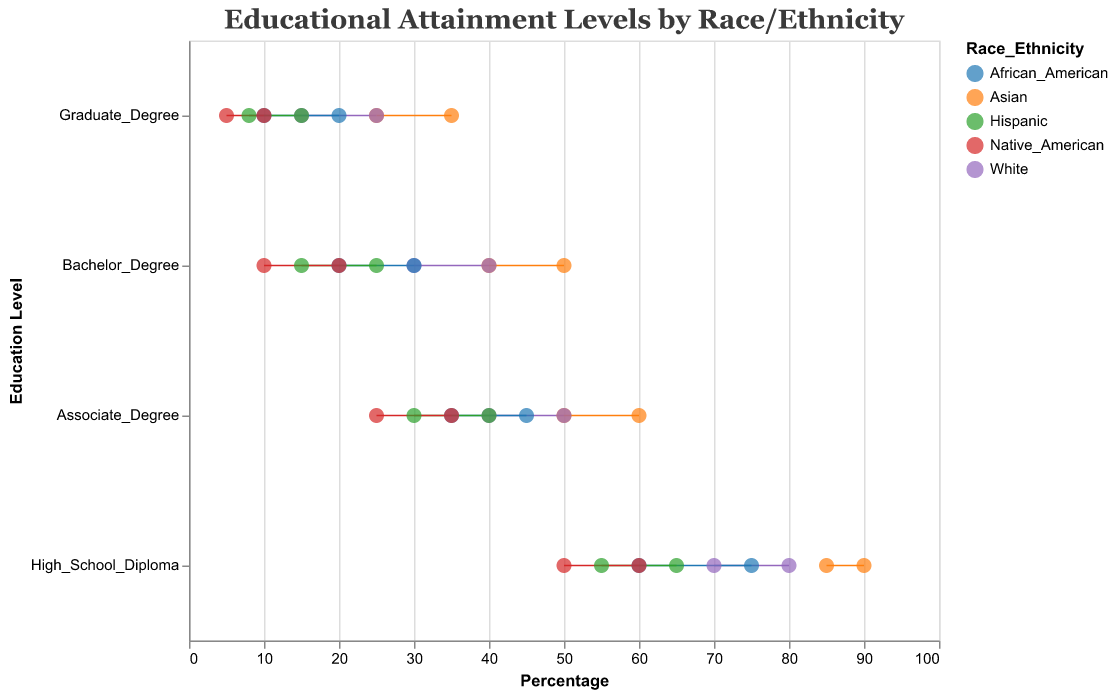What is the title of the figure? The title is given at the top of the figure. It reads "Educational Attainment Levels by Race/Ethnicity".
Answer: Educational Attainment Levels by Race/Ethnicity Which racial or ethnic group has the highest percentage of individuals with a High School Diploma at the starting level? To identify this, we look at the "Percentage_Start" figures for each racial or ethnic group under the "High_School_Diploma" category. The Asian group has the highest value, which is 85%.
Answer: Asian What is the range of percentages for Native Americans with an Associate Degree? Locate the row corresponding to Native Americans under "Associate_Degree" in the data. The starting percentage is 25, and the ending percentage is 35.
Answer: 25% to 35% How does the percentage for African Americans with a Bachelor Degree compare at the starting and ending levels? Locate the African Americans row under "Bachelor_Degree." The starting percentage is 20%, and the ending percentage is 30%. By comparing these two values, you can see that there is an increase of 10%.
Answer: Increase from 20% to 30% What is the difference in percentages at the ending level between Hispanics and Whites with a Graduate Degree? Determine the ending percentages for Hispanics and Whites under the "Graduate_Degree." Hispanics have an ending percentage of 15, while Whites have an ending percentage of 25. Subtract the ending percentage of Hispanics from that of Whites: 25 - 15 = 10.
Answer: 10% Which group shows the smallest change in percentage from start to end in the frame of Bachelor's Degree? Calculate the difference between the starting and ending percentages for each group under "Bachelor_Degree." The differences are:
White: 40 - 30 = 10
African American: 30 - 20 = 10
Hispanic: 25 - 15 = 10
Asian: 50 - 40 = 10
Native American: 20 - 10 = 10 
Since all groups have the same difference, the answer is that all groups show a change of 10%.
Answer: All groups Which education level shows the highest percentage range for African Americans? Compare the starting and ending percentages for African Americans across all education levels. High School Diploma: 75 - 60 = 15 Associate Degree: 45 - 35 = 10 Bachelor Degree: 30 - 20 = 10 Graduate Degree: 20 - 10 = 10 The High School Diploma shows the highest percentage range of 15.
Answer: High School Diploma Do Hispanics show a larger percentage increase with a High School Diploma or an Associate Degree? Determine the percentage increase for Hispanics in both categories:
High School Diploma: 65 - 55 = 10
Associate Degree: 40 - 30 = 10
The increase is the same for both education levels.
Answer: Both are equal What is the percentage change for Asians with a Graduate Degree from start to end? Locate the values for Asians under "Graduate_Degree." The starting percentage is 25%, and the ending percentage is 35%. Calculate the change: 35 - 25 = 10.
Answer: 10% 